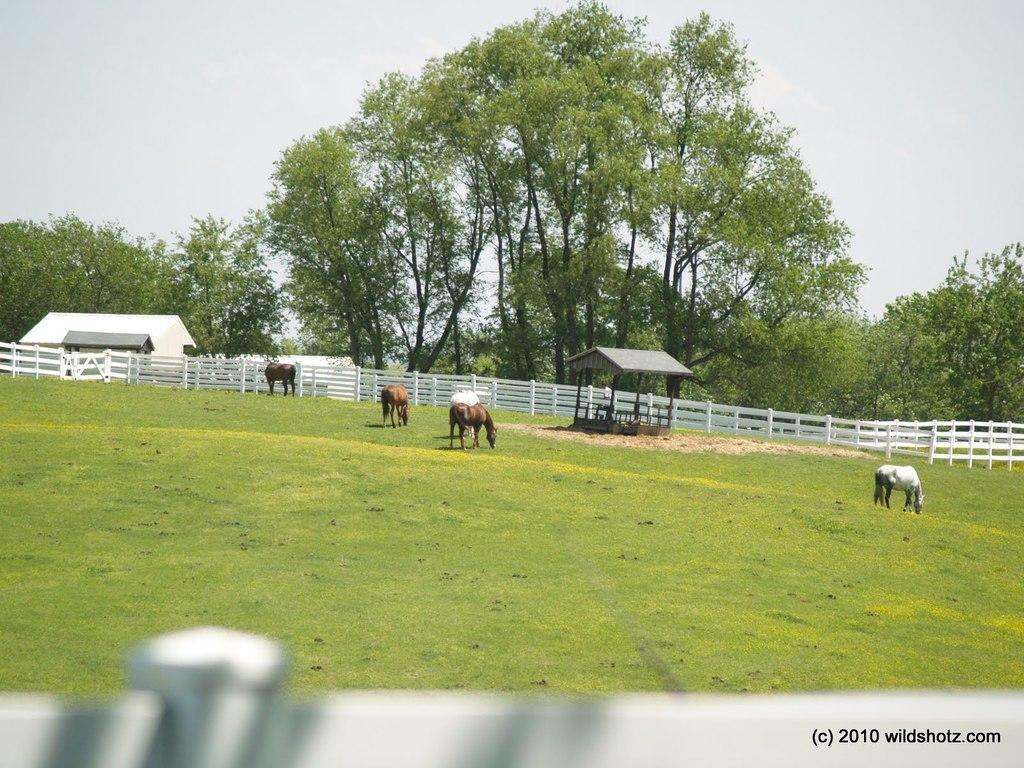Could you give a brief overview of what you see in this image? In this picture we can see the horses, sheds, roofs, fencing, grass. In the background of the image we can see the trees and ground. At the bottom of the image we can see the fencing. In the bottom right corner we can see the text. At the top of the image we can see the sky. 